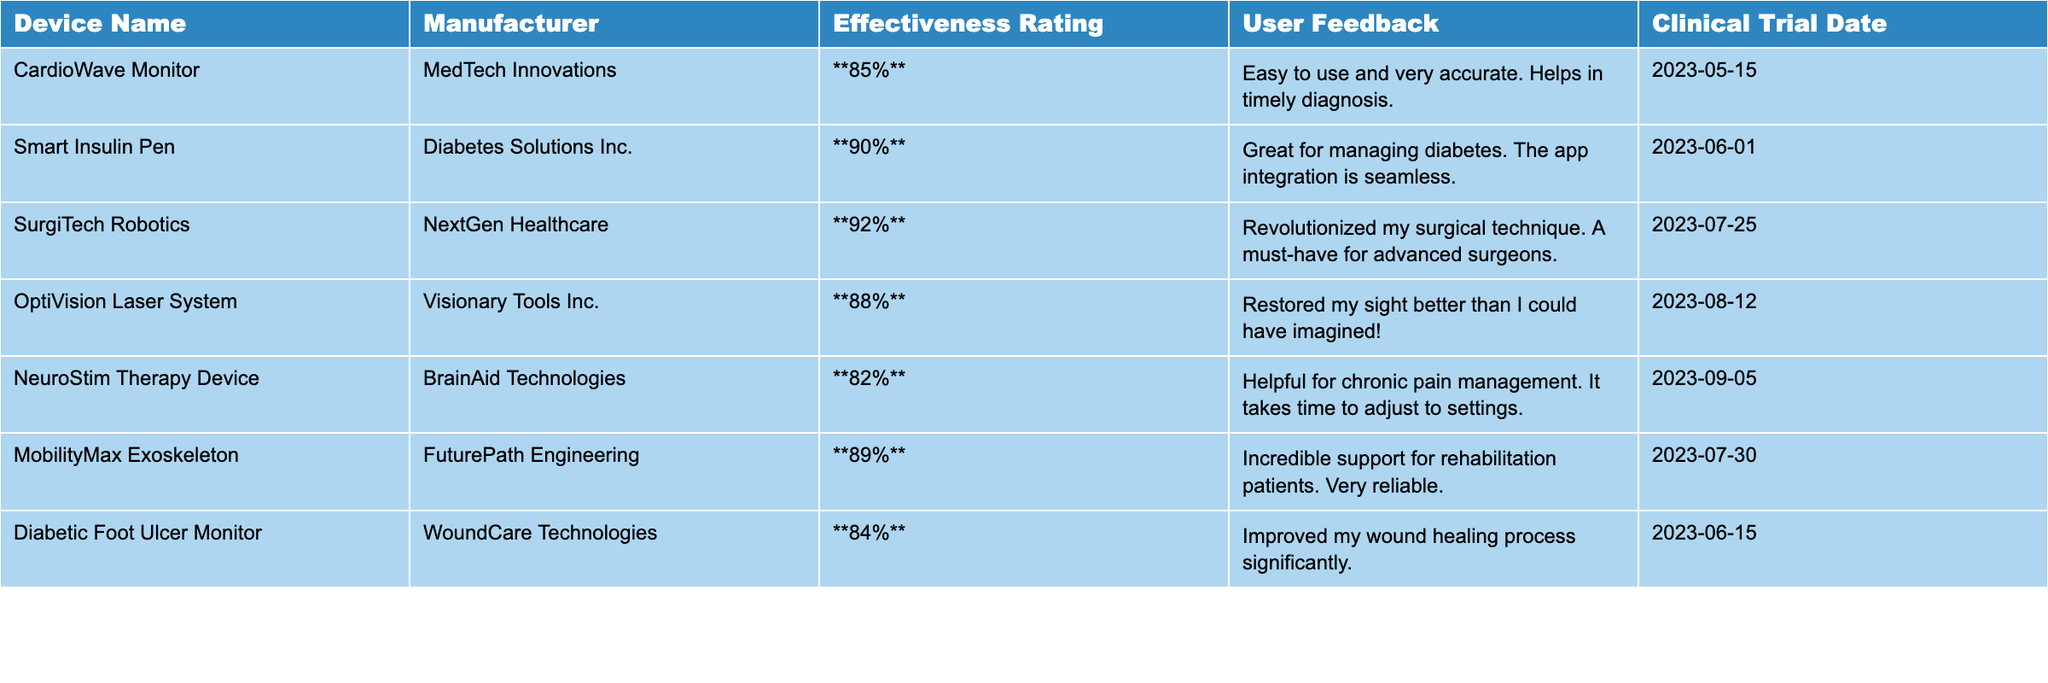What is the effectiveness rating of the SurgiTech Robotics device? The effectiveness rating for the SurgiTech Robotics device is listed in the table. Upon finding the row for this device, I see that the rating is **92%**.
Answer: 92% Which device has the highest effectiveness rating? By scanning through the effectiveness ratings listed in the table, I find that the SurgiTech Robotics device has the highest rating at **92%**.
Answer: SurgiTech Robotics What is the average effectiveness rating of all the devices listed? To find the average rating, I will first sum up all the ratings: 85 + 90 + 92 + 88 + 82 + 89 + 84 = 510. Then I divide by the number of devices, which is 7: 510 / 7 = 72.86 (rounded to two decimal places).
Answer: 72.86% Is the Smart Insulin Pen rated above 85% effectiveness? The effectiveness rating for the Smart Insulin Pen is **90%**, which is greater than 85%. Therefore, the statement is true.
Answer: Yes Which device received user feedback about pain management? In the table, the NeuroStim Therapy Device is specifically mentioned for its feedback regarding chronic pain management. This detail can be found in the User Feedback column.
Answer: NeuroStim Therapy Device If the CardioWave Monitor is rated at 85%, and the NeuroStim Therapy Device at 82%, what is the difference in their effectiveness ratings? The difference can be calculated by subtracting the lower rating from the higher rating: 85 - 82 = 3. Therefore, the difference in effectiveness ratings is 3%.
Answer: 3% How many devices have an effectiveness rating above 85%? Counting the devices from the table, I see that the CardioWave Monitor, Smart Insulin Pen, SurgiTech Robotics, MobilityMax Exoskeleton, and OptiVision Laser System all have effectiveness ratings above 85%. That totals to 5 devices.
Answer: 5 devices Which manufacturer produces the device with the lowest effectiveness rating? Upon checking the effectiveness ratings, the NeuroStim Therapy Device has the lowest rating of **82%**, and it is manufactured by BrainAid Technologies.
Answer: BrainAid Technologies Are there any devices launched after June 2023 with a rating above 88%? The only devices launched after June 2023 are the SurgiTech Robotics (July 25, 2023) rated at 92% and the NeuroStim Therapy Device (September 5, 2023) rated at 82%. Therefore, only the SurgiTech Robotics is above 88%.
Answer: Yes, 1 device What can be inferred from the user feedback on Diabetic Foot Ulcer Monitor? The user feedback indicates that the Diabetic Foot Ulcer Monitor significantly improved the wound healing process, suggesting a positive overall effectiveness in the treatment of diabetic foot ulcers.
Answer: Positive effectiveness 